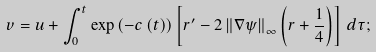Convert formula to latex. <formula><loc_0><loc_0><loc_500><loc_500>v = u + \int _ { 0 } ^ { t } \exp \left ( - c \left ( t \right ) \right ) \left [ r ^ { \prime } - 2 \left \| \nabla \psi \right \| _ { \infty } \left ( r + \frac { 1 } { 4 } \right ) \right ] \, d \tau ;</formula> 